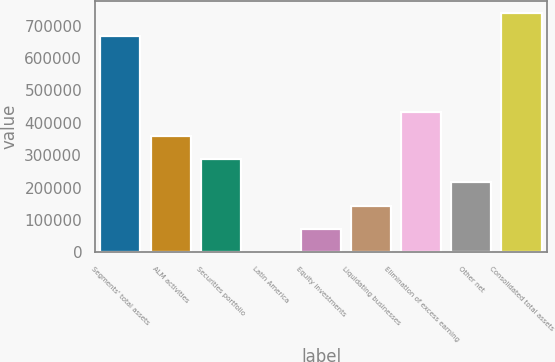Convert chart. <chart><loc_0><loc_0><loc_500><loc_500><bar_chart><fcel>Segments' total assets<fcel>ALM activities<fcel>Securities portfolio<fcel>Latin America<fcel>Equity investments<fcel>Liquidating businesses<fcel>Elimination of excess earning<fcel>Other net<fcel>Consolidated total assets<nl><fcel>667578<fcel>359999<fcel>288102<fcel>515<fcel>72411.8<fcel>144309<fcel>431896<fcel>216205<fcel>739475<nl></chart> 